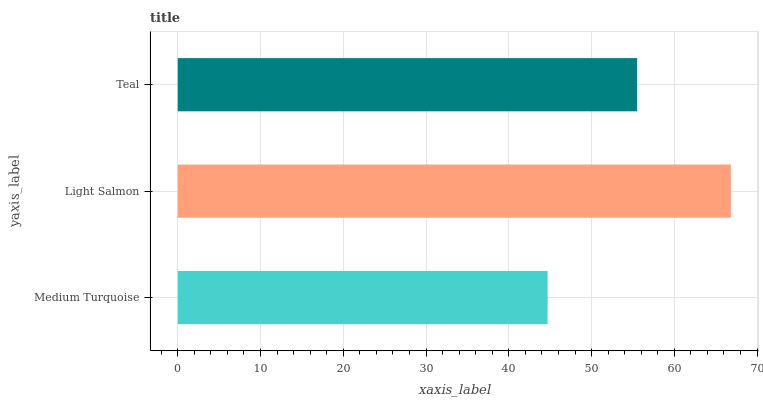Is Medium Turquoise the minimum?
Answer yes or no. Yes. Is Light Salmon the maximum?
Answer yes or no. Yes. Is Teal the minimum?
Answer yes or no. No. Is Teal the maximum?
Answer yes or no. No. Is Light Salmon greater than Teal?
Answer yes or no. Yes. Is Teal less than Light Salmon?
Answer yes or no. Yes. Is Teal greater than Light Salmon?
Answer yes or no. No. Is Light Salmon less than Teal?
Answer yes or no. No. Is Teal the high median?
Answer yes or no. Yes. Is Teal the low median?
Answer yes or no. Yes. Is Light Salmon the high median?
Answer yes or no. No. Is Medium Turquoise the low median?
Answer yes or no. No. 